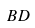<formula> <loc_0><loc_0><loc_500><loc_500>B D</formula> 